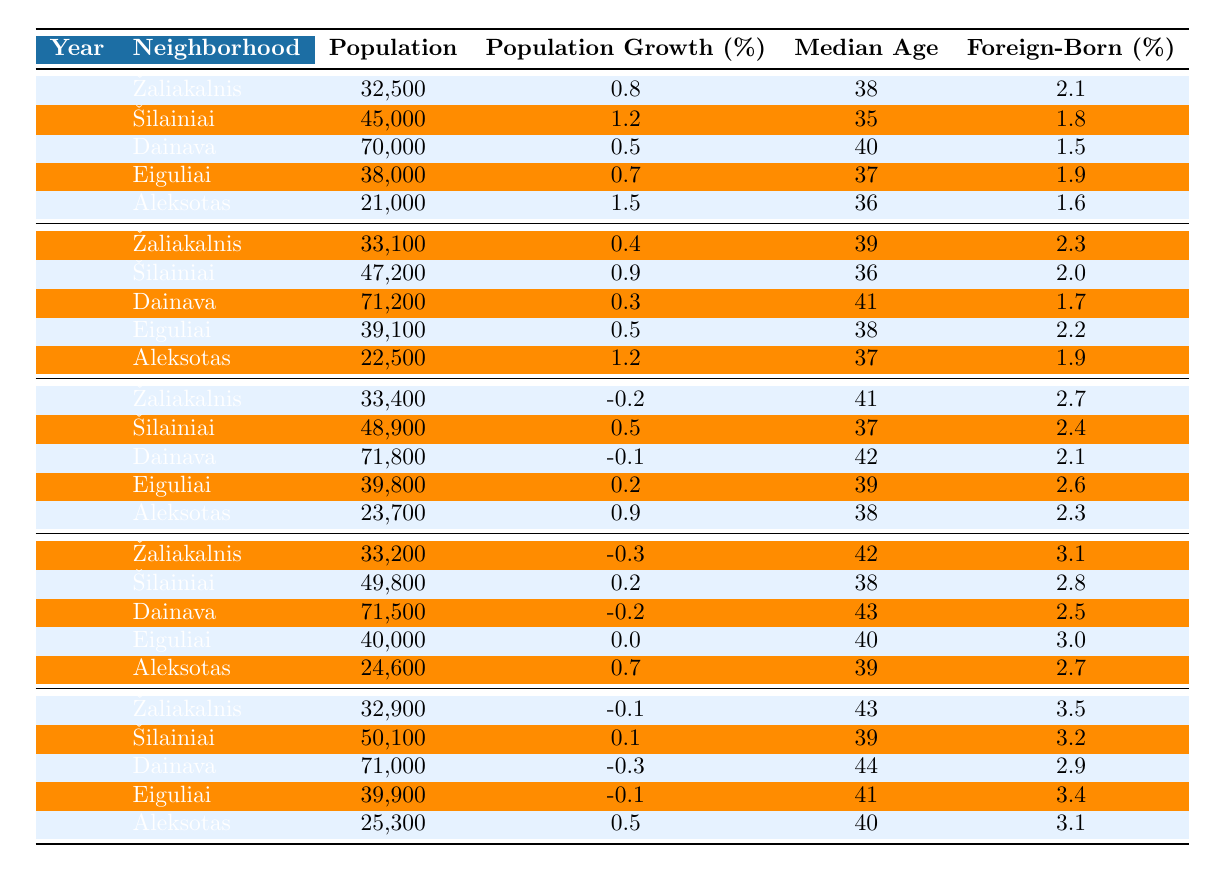What was the population of Dainava in 2010? Referring to the table, the population of Dainava in 2010 is listed as 71,800.
Answer: 71,800 Which neighborhood had the highest population in 2000? In the 2000 data, Dainava has the highest population at 70,000, compared to other neighborhoods.
Answer: Dainava What was the population growth percentage for Šilainiai between 2015 and 2020? The population growth of Šilainiai in 2015 was 49,800, and in 2020, it was 50,100. Therefore, the percentage change is (50,100 - 49,800) / 49,800 * 100 = 0.6%, which rounds to 0.1%.
Answer: 0.1% What is the median age of inhabitants in Aleksotas as of 2020? The data shows that the median age in Aleksotas for the year 2020 is 40 years.
Answer: 40 Which neighborhood had the largest decline in population growth from 2000 to 2020? By comparing the population growth percentages over the years, Dainava shows the most significant decline, going from a 0.5% increase in 2000 to a -0.3% decrease in 2020, resulting in a total decline of 0.8%.
Answer: Dainava Did Eiguliai experience any growth from 2010 to 2015? The percentage change for Eiguliai from 2010 (39,800) to 2015 (40,000) indicates a population growth of 0.0%, meaning there was no significant growth.
Answer: No What neighborhood had the highest foreign-born population percentage in 2020? Looking at the foreign-born population percentages in 2020, Žaliakalnis has the highest at 3.5%, compared to the other neighborhoods.
Answer: Žaliakalnis Based on the table, what was the average median age of residents across all neighborhoods in 2015? Adding the median ages for all neighborhoods in 2015 results in (42 + 38 + 43 + 40 + 39) = 202. Dividing by the number of neighborhoods (5), the average median age is 202 / 5 = 40.4, which rounds to 40.
Answer: 40.4 What change occurred in population from 2000 to 2020 for Žaliakalnis? The population for Žaliakalnis decreased from 32,500 in 2000 to 32,900 in 2020, resulting in a decline of 600 people.
Answer: Decline Which neighborhood showed consistent population growth from 2000 to 2005? In the data, Šilainiai consistently showed positive growth percentages from 2000 (1.2%) to 2005 (0.9%), indicating growth during that time.
Answer: Šilainiai 